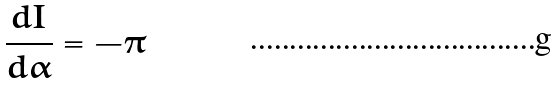<formula> <loc_0><loc_0><loc_500><loc_500>\frac { d I } { d \alpha } = - \pi</formula> 